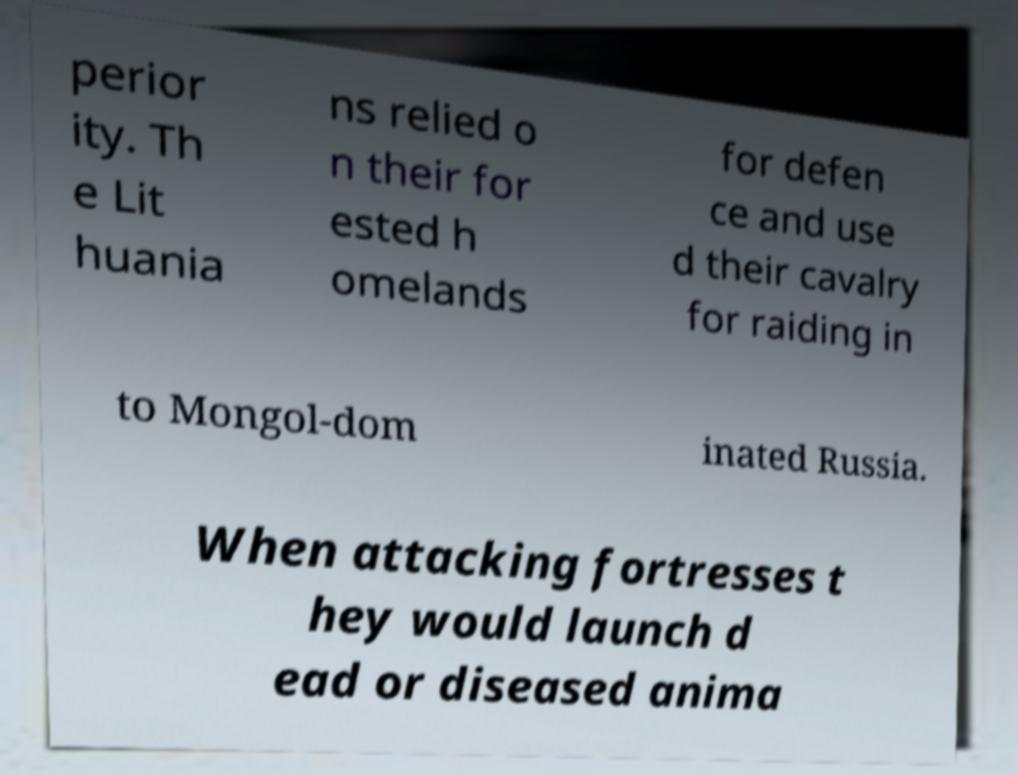Can you read and provide the text displayed in the image?This photo seems to have some interesting text. Can you extract and type it out for me? perior ity. Th e Lit huania ns relied o n their for ested h omelands for defen ce and use d their cavalry for raiding in to Mongol-dom inated Russia. When attacking fortresses t hey would launch d ead or diseased anima 